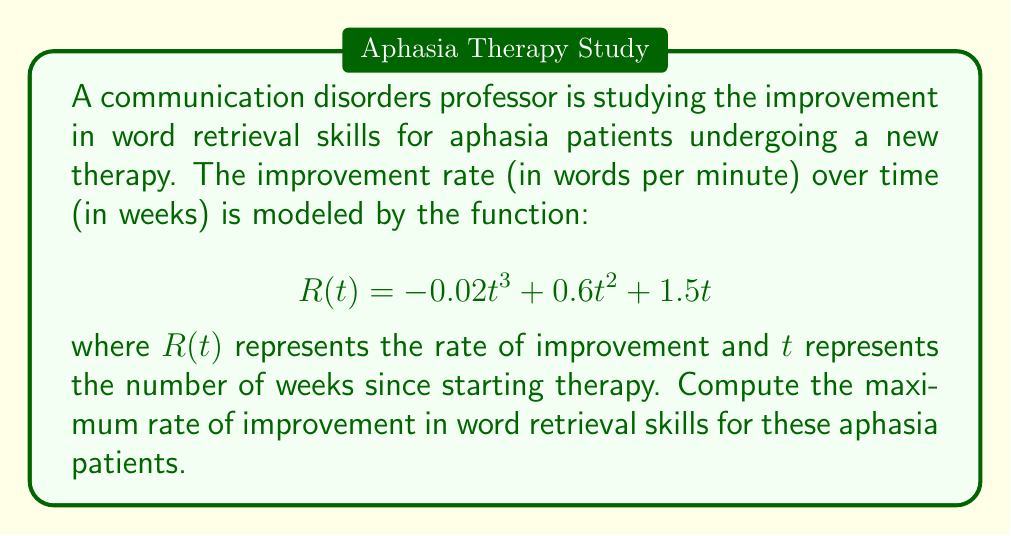Show me your answer to this math problem. To find the maximum rate of improvement, we need to follow these steps:

1. Find the derivative of $R(t)$ with respect to $t$:
   $$R'(t) = -0.06t^2 + 1.2t + 1.5$$

2. Set $R'(t) = 0$ to find the critical points:
   $$-0.06t^2 + 1.2t + 1.5 = 0$$

3. Solve the quadratic equation:
   $$t = \frac{-1.2 \pm \sqrt{1.2^2 - 4(-0.06)(1.5)}}{2(-0.06)}$$
   $$t = \frac{-1.2 \pm \sqrt{1.44 + 0.36}}{-0.12}$$
   $$t = \frac{-1.2 \pm \sqrt{1.8}}{-0.12}$$
   $$t = \frac{-1.2 \pm 1.34164}}{-0.12}$$

   This gives us two critical points:
   $t_1 = \frac{-1.2 + 1.34164}{-0.12} \approx 1.18$
   $t_2 = \frac{-1.2 - 1.34164}{-0.12} \approx 21.18$

4. Evaluate $R''(t)$ to determine the nature of these critical points:
   $$R''(t) = -0.12t + 1.2$$
   
   At $t_1 \approx 1.18$: $R''(1.18) \approx 1.0584 > 0$ (local minimum)
   At $t_2 \approx 21.18$: $R''(21.18) \approx -1.3416 < 0$ (local maximum)

5. Calculate the maximum rate of improvement at $t_2 \approx 21.18$:
   $$R(21.18) = -0.02(21.18)^3 + 0.6(21.18)^2 + 1.5(21.18)$$
   $$R(21.18) \approx 27.05$$ words per minute
Answer: 27.05 words per minute 